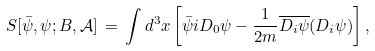<formula> <loc_0><loc_0><loc_500><loc_500>S [ { \bar { \psi } } , \psi ; B , { \mathcal { A } } ] \, = \, \int d ^ { 3 } x \left [ { \bar { \psi } } i D _ { 0 } \psi - \frac { 1 } { 2 m } \overline { D _ { i } \psi } ( D _ { i } \psi ) \right ] ,</formula> 